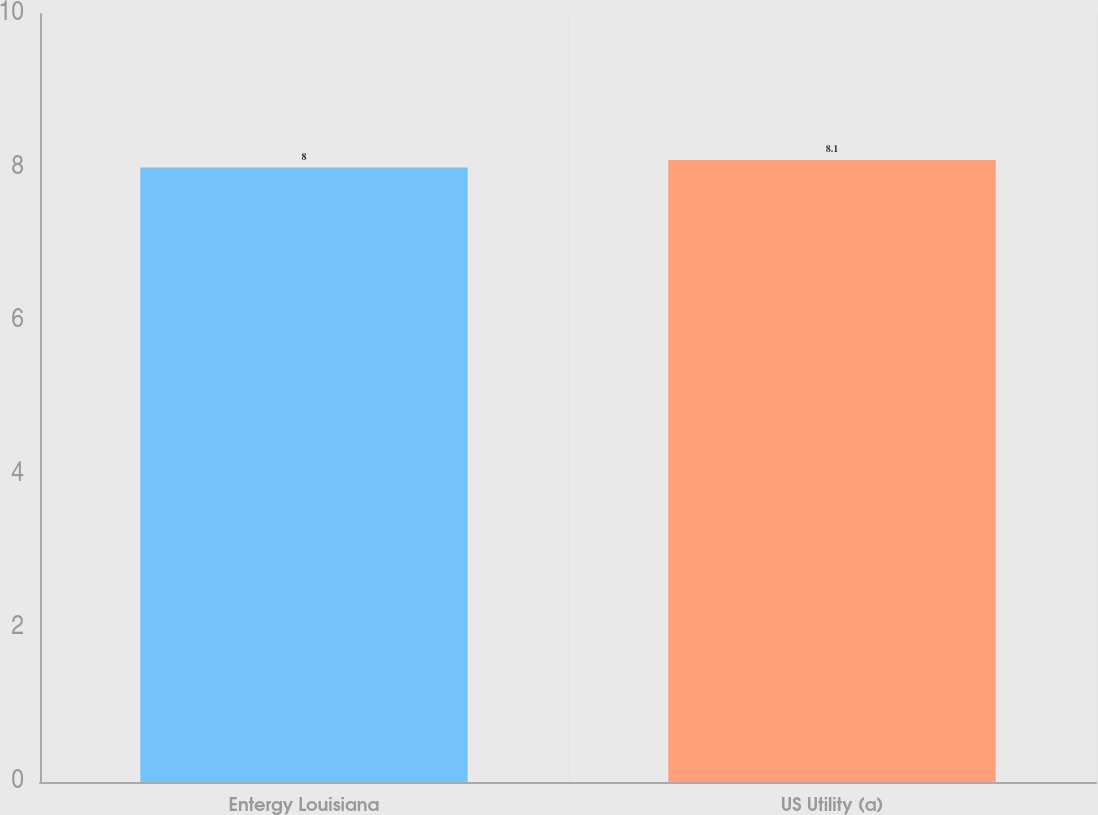Convert chart. <chart><loc_0><loc_0><loc_500><loc_500><bar_chart><fcel>Entergy Louisiana<fcel>US Utility (a)<nl><fcel>8<fcel>8.1<nl></chart> 